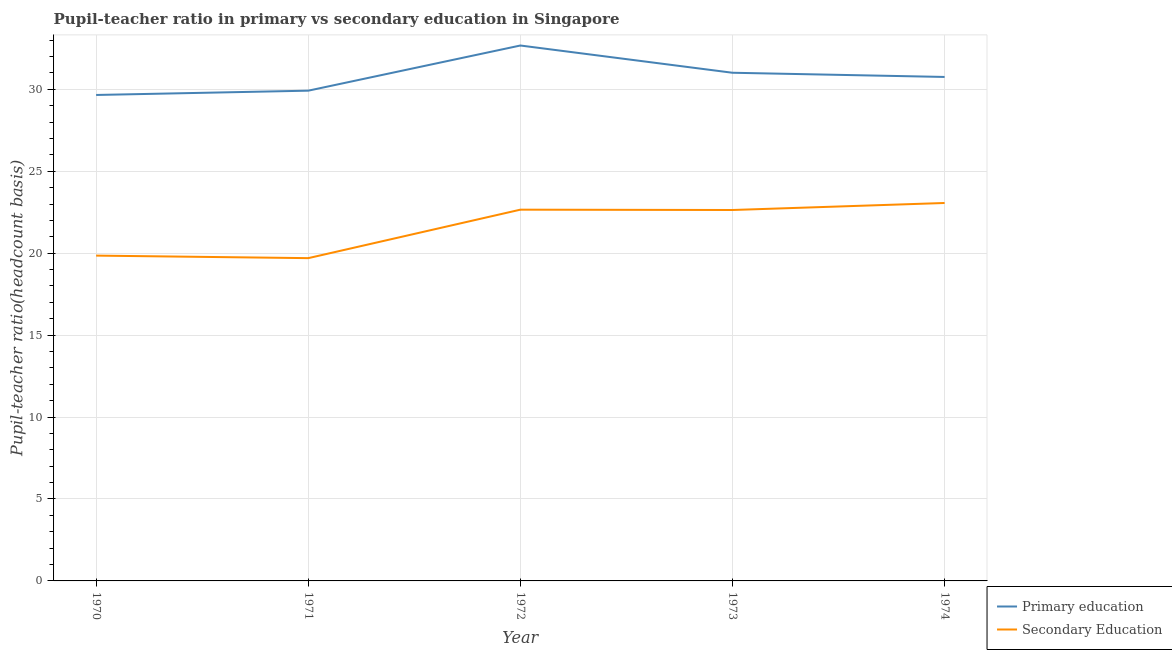How many different coloured lines are there?
Ensure brevity in your answer.  2. What is the pupil teacher ratio on secondary education in 1974?
Provide a short and direct response. 23.06. Across all years, what is the maximum pupil teacher ratio on secondary education?
Your answer should be compact. 23.06. Across all years, what is the minimum pupil-teacher ratio in primary education?
Provide a short and direct response. 29.65. What is the total pupil teacher ratio on secondary education in the graph?
Offer a terse response. 107.9. What is the difference between the pupil-teacher ratio in primary education in 1970 and that in 1971?
Your response must be concise. -0.26. What is the difference between the pupil teacher ratio on secondary education in 1970 and the pupil-teacher ratio in primary education in 1972?
Keep it short and to the point. -12.82. What is the average pupil-teacher ratio in primary education per year?
Your answer should be compact. 30.8. In the year 1973, what is the difference between the pupil teacher ratio on secondary education and pupil-teacher ratio in primary education?
Keep it short and to the point. -8.37. In how many years, is the pupil teacher ratio on secondary education greater than 1?
Offer a terse response. 5. What is the ratio of the pupil teacher ratio on secondary education in 1971 to that in 1974?
Keep it short and to the point. 0.85. Is the pupil teacher ratio on secondary education in 1973 less than that in 1974?
Your answer should be compact. Yes. What is the difference between the highest and the second highest pupil-teacher ratio in primary education?
Your response must be concise. 1.66. What is the difference between the highest and the lowest pupil teacher ratio on secondary education?
Make the answer very short. 3.37. In how many years, is the pupil-teacher ratio in primary education greater than the average pupil-teacher ratio in primary education taken over all years?
Your answer should be very brief. 2. Is the sum of the pupil teacher ratio on secondary education in 1971 and 1973 greater than the maximum pupil-teacher ratio in primary education across all years?
Your answer should be very brief. Yes. How many years are there in the graph?
Ensure brevity in your answer.  5. What is the difference between two consecutive major ticks on the Y-axis?
Give a very brief answer. 5. Does the graph contain grids?
Your answer should be compact. Yes. How many legend labels are there?
Give a very brief answer. 2. How are the legend labels stacked?
Provide a short and direct response. Vertical. What is the title of the graph?
Provide a short and direct response. Pupil-teacher ratio in primary vs secondary education in Singapore. Does "Electricity" appear as one of the legend labels in the graph?
Your response must be concise. No. What is the label or title of the X-axis?
Provide a succinct answer. Year. What is the label or title of the Y-axis?
Provide a short and direct response. Pupil-teacher ratio(headcount basis). What is the Pupil-teacher ratio(headcount basis) in Primary education in 1970?
Offer a very short reply. 29.65. What is the Pupil-teacher ratio(headcount basis) of Secondary Education in 1970?
Your answer should be very brief. 19.85. What is the Pupil-teacher ratio(headcount basis) in Primary education in 1971?
Keep it short and to the point. 29.92. What is the Pupil-teacher ratio(headcount basis) in Secondary Education in 1971?
Give a very brief answer. 19.7. What is the Pupil-teacher ratio(headcount basis) of Primary education in 1972?
Ensure brevity in your answer.  32.67. What is the Pupil-teacher ratio(headcount basis) in Secondary Education in 1972?
Provide a short and direct response. 22.65. What is the Pupil-teacher ratio(headcount basis) in Primary education in 1973?
Offer a terse response. 31.01. What is the Pupil-teacher ratio(headcount basis) of Secondary Education in 1973?
Keep it short and to the point. 22.63. What is the Pupil-teacher ratio(headcount basis) in Primary education in 1974?
Your response must be concise. 30.75. What is the Pupil-teacher ratio(headcount basis) of Secondary Education in 1974?
Ensure brevity in your answer.  23.06. Across all years, what is the maximum Pupil-teacher ratio(headcount basis) in Primary education?
Offer a terse response. 32.67. Across all years, what is the maximum Pupil-teacher ratio(headcount basis) in Secondary Education?
Your response must be concise. 23.06. Across all years, what is the minimum Pupil-teacher ratio(headcount basis) in Primary education?
Offer a terse response. 29.65. Across all years, what is the minimum Pupil-teacher ratio(headcount basis) of Secondary Education?
Offer a terse response. 19.7. What is the total Pupil-teacher ratio(headcount basis) in Primary education in the graph?
Your answer should be very brief. 154. What is the total Pupil-teacher ratio(headcount basis) of Secondary Education in the graph?
Your answer should be very brief. 107.9. What is the difference between the Pupil-teacher ratio(headcount basis) in Primary education in 1970 and that in 1971?
Ensure brevity in your answer.  -0.26. What is the difference between the Pupil-teacher ratio(headcount basis) in Secondary Education in 1970 and that in 1971?
Keep it short and to the point. 0.15. What is the difference between the Pupil-teacher ratio(headcount basis) of Primary education in 1970 and that in 1972?
Keep it short and to the point. -3.02. What is the difference between the Pupil-teacher ratio(headcount basis) in Secondary Education in 1970 and that in 1972?
Give a very brief answer. -2.8. What is the difference between the Pupil-teacher ratio(headcount basis) of Primary education in 1970 and that in 1973?
Offer a very short reply. -1.36. What is the difference between the Pupil-teacher ratio(headcount basis) in Secondary Education in 1970 and that in 1973?
Your answer should be very brief. -2.78. What is the difference between the Pupil-teacher ratio(headcount basis) of Primary education in 1970 and that in 1974?
Your response must be concise. -1.1. What is the difference between the Pupil-teacher ratio(headcount basis) of Secondary Education in 1970 and that in 1974?
Your answer should be very brief. -3.21. What is the difference between the Pupil-teacher ratio(headcount basis) in Primary education in 1971 and that in 1972?
Provide a short and direct response. -2.76. What is the difference between the Pupil-teacher ratio(headcount basis) of Secondary Education in 1971 and that in 1972?
Your answer should be very brief. -2.96. What is the difference between the Pupil-teacher ratio(headcount basis) of Primary education in 1971 and that in 1973?
Give a very brief answer. -1.09. What is the difference between the Pupil-teacher ratio(headcount basis) in Secondary Education in 1971 and that in 1973?
Your answer should be compact. -2.94. What is the difference between the Pupil-teacher ratio(headcount basis) in Primary education in 1971 and that in 1974?
Provide a short and direct response. -0.84. What is the difference between the Pupil-teacher ratio(headcount basis) in Secondary Education in 1971 and that in 1974?
Provide a short and direct response. -3.37. What is the difference between the Pupil-teacher ratio(headcount basis) in Primary education in 1972 and that in 1973?
Make the answer very short. 1.66. What is the difference between the Pupil-teacher ratio(headcount basis) in Secondary Education in 1972 and that in 1973?
Give a very brief answer. 0.02. What is the difference between the Pupil-teacher ratio(headcount basis) in Primary education in 1972 and that in 1974?
Offer a terse response. 1.92. What is the difference between the Pupil-teacher ratio(headcount basis) of Secondary Education in 1972 and that in 1974?
Make the answer very short. -0.41. What is the difference between the Pupil-teacher ratio(headcount basis) in Primary education in 1973 and that in 1974?
Ensure brevity in your answer.  0.26. What is the difference between the Pupil-teacher ratio(headcount basis) in Secondary Education in 1973 and that in 1974?
Provide a succinct answer. -0.43. What is the difference between the Pupil-teacher ratio(headcount basis) in Primary education in 1970 and the Pupil-teacher ratio(headcount basis) in Secondary Education in 1971?
Keep it short and to the point. 9.96. What is the difference between the Pupil-teacher ratio(headcount basis) of Primary education in 1970 and the Pupil-teacher ratio(headcount basis) of Secondary Education in 1972?
Your answer should be compact. 7. What is the difference between the Pupil-teacher ratio(headcount basis) in Primary education in 1970 and the Pupil-teacher ratio(headcount basis) in Secondary Education in 1973?
Provide a succinct answer. 7.02. What is the difference between the Pupil-teacher ratio(headcount basis) in Primary education in 1970 and the Pupil-teacher ratio(headcount basis) in Secondary Education in 1974?
Give a very brief answer. 6.59. What is the difference between the Pupil-teacher ratio(headcount basis) in Primary education in 1971 and the Pupil-teacher ratio(headcount basis) in Secondary Education in 1972?
Provide a short and direct response. 7.26. What is the difference between the Pupil-teacher ratio(headcount basis) of Primary education in 1971 and the Pupil-teacher ratio(headcount basis) of Secondary Education in 1973?
Your response must be concise. 7.28. What is the difference between the Pupil-teacher ratio(headcount basis) of Primary education in 1971 and the Pupil-teacher ratio(headcount basis) of Secondary Education in 1974?
Provide a short and direct response. 6.85. What is the difference between the Pupil-teacher ratio(headcount basis) of Primary education in 1972 and the Pupil-teacher ratio(headcount basis) of Secondary Education in 1973?
Give a very brief answer. 10.04. What is the difference between the Pupil-teacher ratio(headcount basis) in Primary education in 1972 and the Pupil-teacher ratio(headcount basis) in Secondary Education in 1974?
Ensure brevity in your answer.  9.61. What is the difference between the Pupil-teacher ratio(headcount basis) in Primary education in 1973 and the Pupil-teacher ratio(headcount basis) in Secondary Education in 1974?
Make the answer very short. 7.95. What is the average Pupil-teacher ratio(headcount basis) of Primary education per year?
Keep it short and to the point. 30.8. What is the average Pupil-teacher ratio(headcount basis) in Secondary Education per year?
Your answer should be very brief. 21.58. In the year 1970, what is the difference between the Pupil-teacher ratio(headcount basis) of Primary education and Pupil-teacher ratio(headcount basis) of Secondary Education?
Keep it short and to the point. 9.8. In the year 1971, what is the difference between the Pupil-teacher ratio(headcount basis) in Primary education and Pupil-teacher ratio(headcount basis) in Secondary Education?
Your answer should be compact. 10.22. In the year 1972, what is the difference between the Pupil-teacher ratio(headcount basis) in Primary education and Pupil-teacher ratio(headcount basis) in Secondary Education?
Provide a short and direct response. 10.02. In the year 1973, what is the difference between the Pupil-teacher ratio(headcount basis) of Primary education and Pupil-teacher ratio(headcount basis) of Secondary Education?
Offer a very short reply. 8.37. In the year 1974, what is the difference between the Pupil-teacher ratio(headcount basis) in Primary education and Pupil-teacher ratio(headcount basis) in Secondary Education?
Offer a terse response. 7.69. What is the ratio of the Pupil-teacher ratio(headcount basis) in Primary education in 1970 to that in 1971?
Make the answer very short. 0.99. What is the ratio of the Pupil-teacher ratio(headcount basis) of Secondary Education in 1970 to that in 1971?
Your answer should be compact. 1.01. What is the ratio of the Pupil-teacher ratio(headcount basis) of Primary education in 1970 to that in 1972?
Your answer should be compact. 0.91. What is the ratio of the Pupil-teacher ratio(headcount basis) in Secondary Education in 1970 to that in 1972?
Your answer should be very brief. 0.88. What is the ratio of the Pupil-teacher ratio(headcount basis) in Primary education in 1970 to that in 1973?
Make the answer very short. 0.96. What is the ratio of the Pupil-teacher ratio(headcount basis) in Secondary Education in 1970 to that in 1973?
Provide a succinct answer. 0.88. What is the ratio of the Pupil-teacher ratio(headcount basis) in Secondary Education in 1970 to that in 1974?
Your answer should be compact. 0.86. What is the ratio of the Pupil-teacher ratio(headcount basis) of Primary education in 1971 to that in 1972?
Provide a short and direct response. 0.92. What is the ratio of the Pupil-teacher ratio(headcount basis) of Secondary Education in 1971 to that in 1972?
Offer a very short reply. 0.87. What is the ratio of the Pupil-teacher ratio(headcount basis) of Primary education in 1971 to that in 1973?
Make the answer very short. 0.96. What is the ratio of the Pupil-teacher ratio(headcount basis) of Secondary Education in 1971 to that in 1973?
Ensure brevity in your answer.  0.87. What is the ratio of the Pupil-teacher ratio(headcount basis) in Primary education in 1971 to that in 1974?
Ensure brevity in your answer.  0.97. What is the ratio of the Pupil-teacher ratio(headcount basis) in Secondary Education in 1971 to that in 1974?
Ensure brevity in your answer.  0.85. What is the ratio of the Pupil-teacher ratio(headcount basis) of Primary education in 1972 to that in 1973?
Provide a succinct answer. 1.05. What is the ratio of the Pupil-teacher ratio(headcount basis) of Primary education in 1972 to that in 1974?
Keep it short and to the point. 1.06. What is the ratio of the Pupil-teacher ratio(headcount basis) of Secondary Education in 1972 to that in 1974?
Offer a terse response. 0.98. What is the ratio of the Pupil-teacher ratio(headcount basis) of Primary education in 1973 to that in 1974?
Your answer should be compact. 1.01. What is the ratio of the Pupil-teacher ratio(headcount basis) of Secondary Education in 1973 to that in 1974?
Your answer should be very brief. 0.98. What is the difference between the highest and the second highest Pupil-teacher ratio(headcount basis) of Primary education?
Make the answer very short. 1.66. What is the difference between the highest and the second highest Pupil-teacher ratio(headcount basis) of Secondary Education?
Your answer should be compact. 0.41. What is the difference between the highest and the lowest Pupil-teacher ratio(headcount basis) of Primary education?
Provide a succinct answer. 3.02. What is the difference between the highest and the lowest Pupil-teacher ratio(headcount basis) of Secondary Education?
Keep it short and to the point. 3.37. 